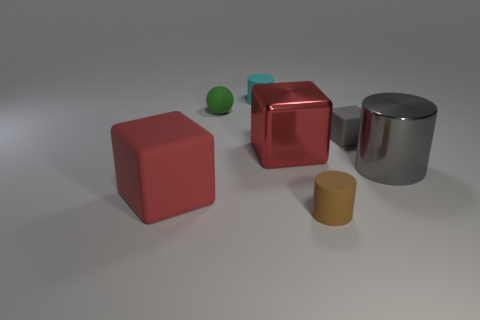Add 1 tiny rubber blocks. How many objects exist? 8 Subtract all cubes. How many objects are left? 4 Add 5 tiny green spheres. How many tiny green spheres are left? 6 Add 6 purple matte cylinders. How many purple matte cylinders exist? 6 Subtract 1 brown cylinders. How many objects are left? 6 Subtract all blocks. Subtract all cylinders. How many objects are left? 1 